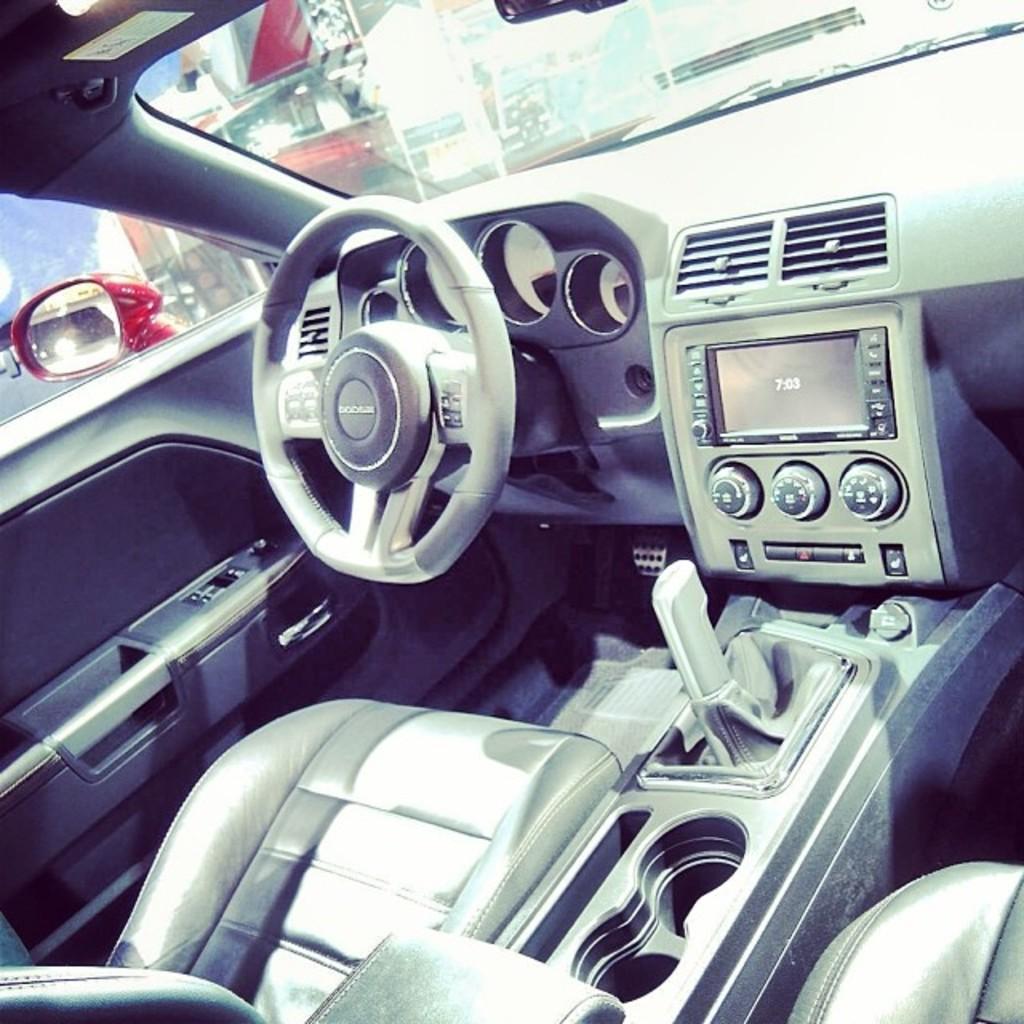Could you give a brief overview of what you see in this image? We can see inside of the vehicle and we can see steering wheel,gear rod,radio,seat and glass windows,through this window we can see side mirror. 